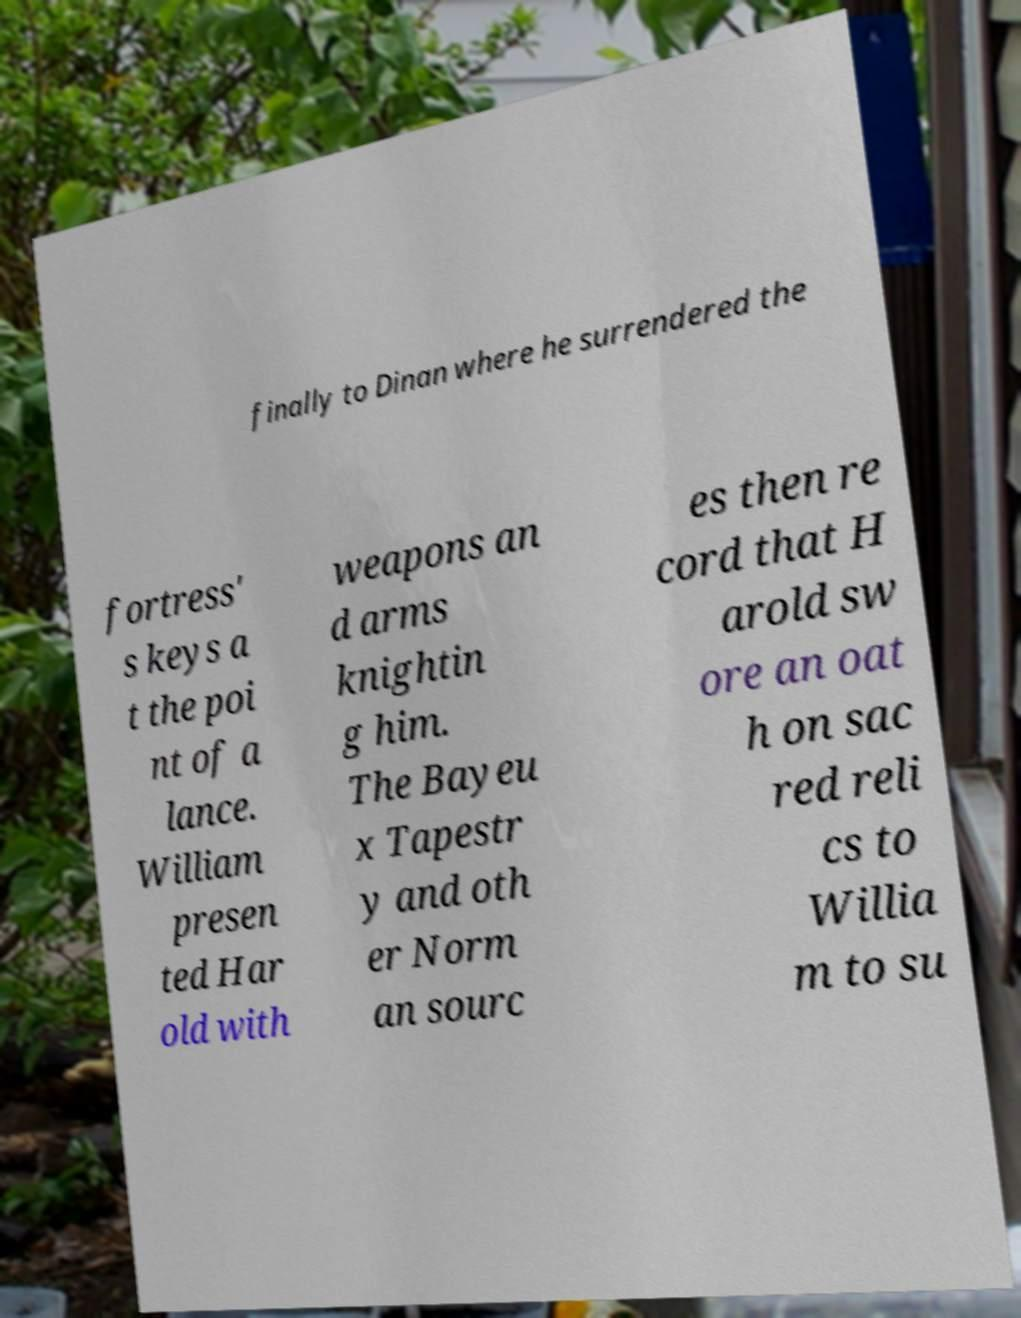Please identify and transcribe the text found in this image. finally to Dinan where he surrendered the fortress' s keys a t the poi nt of a lance. William presen ted Har old with weapons an d arms knightin g him. The Bayeu x Tapestr y and oth er Norm an sourc es then re cord that H arold sw ore an oat h on sac red reli cs to Willia m to su 